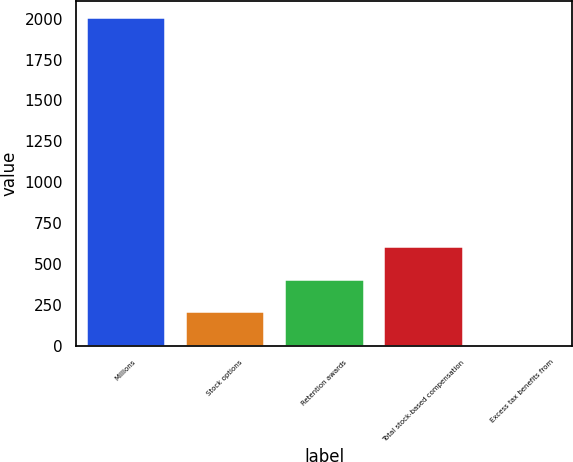<chart> <loc_0><loc_0><loc_500><loc_500><bar_chart><fcel>Millions<fcel>Stock options<fcel>Retention awards<fcel>Total stock-based compensation<fcel>Excess tax benefits from<nl><fcel>2009<fcel>209.9<fcel>409.8<fcel>609.7<fcel>10<nl></chart> 